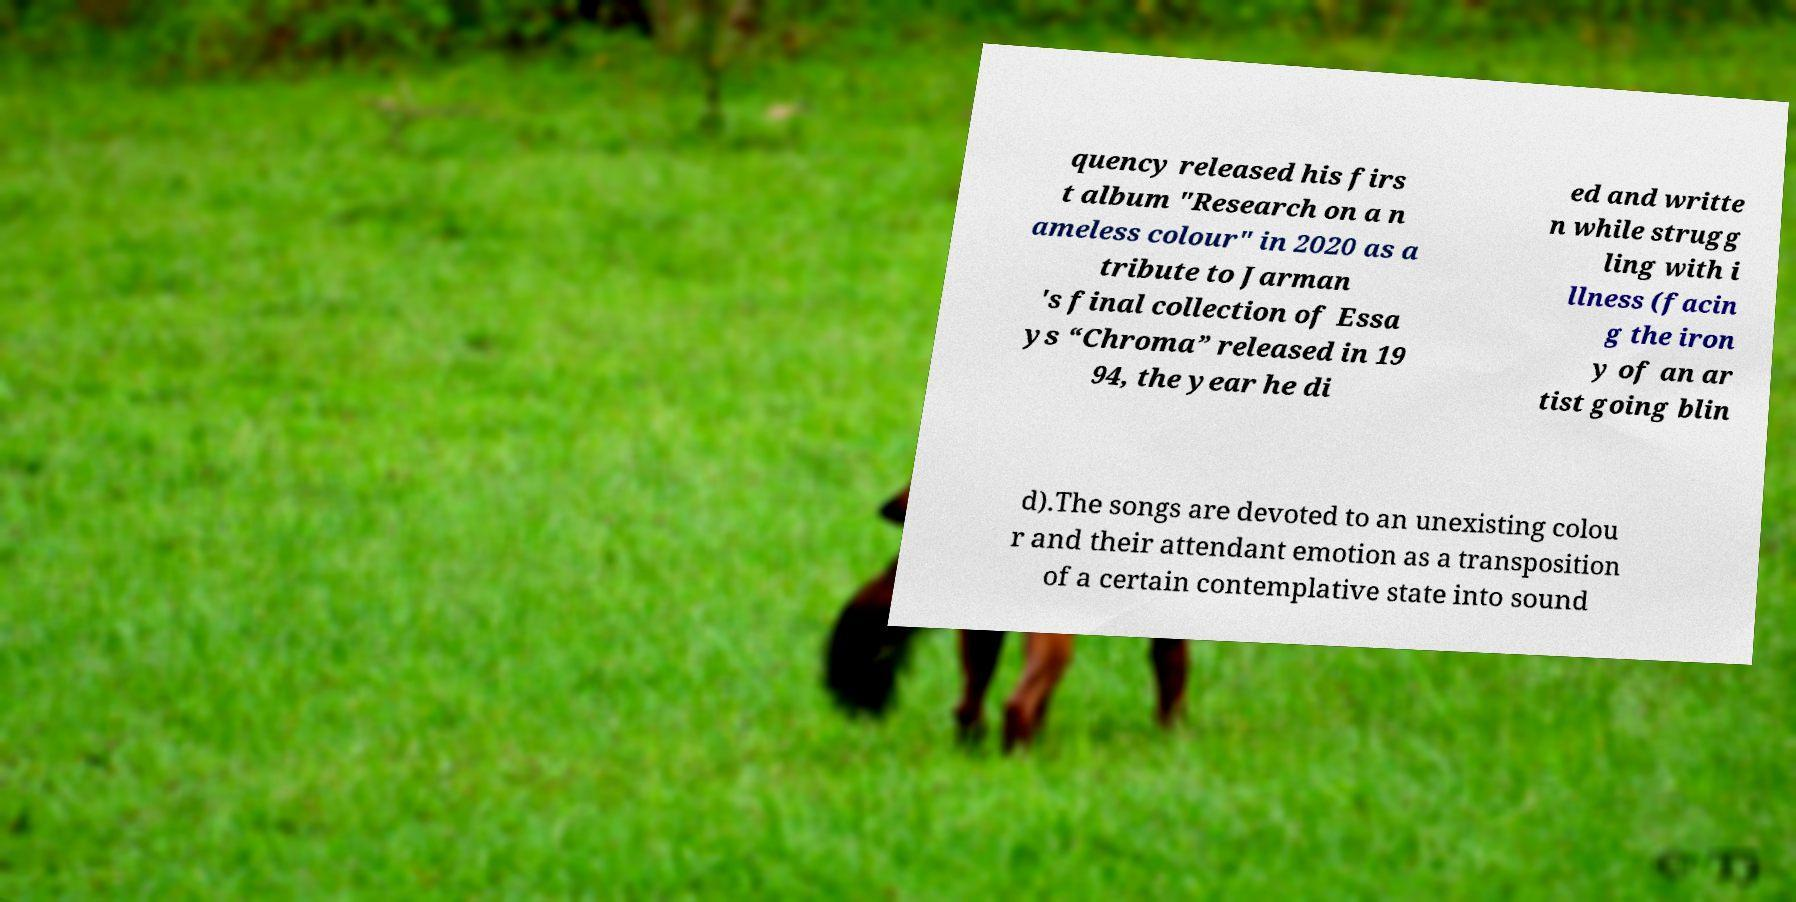Can you accurately transcribe the text from the provided image for me? quency released his firs t album "Research on a n ameless colour" in 2020 as a tribute to Jarman 's final collection of Essa ys “Chroma” released in 19 94, the year he di ed and writte n while strugg ling with i llness (facin g the iron y of an ar tist going blin d).The songs are devoted to an unexisting colou r and their attendant emotion as a transposition of a certain contemplative state into sound 